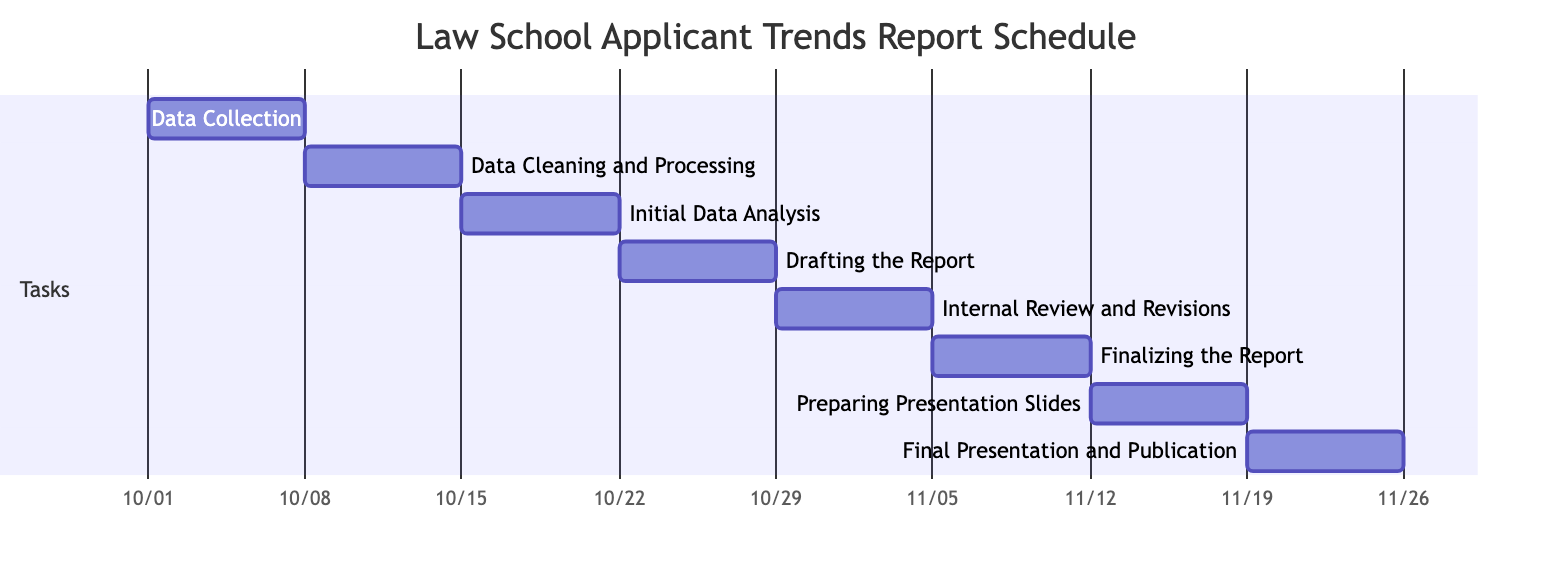What is the duration of the "Data Cleaning and Processing" task? The "Data Cleaning and Processing" task lasts from October 8 to October 14. This is a total of 7 days.
Answer: 7 days What is the start date of the "Final Presentation and Publication"? The "Final Presentation and Publication" task starts on November 19, based on the diagram's timeline.
Answer: November 19 Which task occurs immediately after "Drafting the Report"? The next task after "Drafting the Report" is "Internal Review and Revisions" as depicted in the sequencing of the Gantt Chart.
Answer: Internal Review and Revisions How many tasks are scheduled between "Data Collection" and "Final Presentation and Publication"? The tasks scheduled in between include "Data Cleaning and Processing," "Initial Data Analysis," "Drafting the Report," "Internal Review and Revisions," "Finalizing the Report," and "Preparing Presentation Slides," which totals to 6 tasks.
Answer: 6 tasks What is the total duration of the project as displayed in the Gantt Chart? The project starts on October 1 and ends on November 25, resulting in a total duration of 55 days.
Answer: 55 days At what point in the schedule do the "Preparing Presentation Slides" and "Finalizing the Report" tasks overlap, if at all? The "Preparing Presentation Slides" starts on November 12 and "Finalizing the Report" ends on November 11, so they do not overlap; "Finalizing the Report" concludes before "Preparing Presentation Slides" starts.
Answer: No overlap How does the overlap between "Internal Review and Revisions" and "Drafting the Report" compare to the total project duration? There is no overlap between "Internal Review and Revisions" and "Drafting the Report," meaning those tasks are sequential, contributing to the linear progress of the entire project duration.
Answer: No overlap Which task is the first in the schedule? The "Data Collection" task is the first one scheduled at the start date of October 1.
Answer: Data Collection What is the end date of the "Finalizing the Report" task? The "Finalizing the Report" task ends on November 11 according to the Gantt Chart.
Answer: November 11 